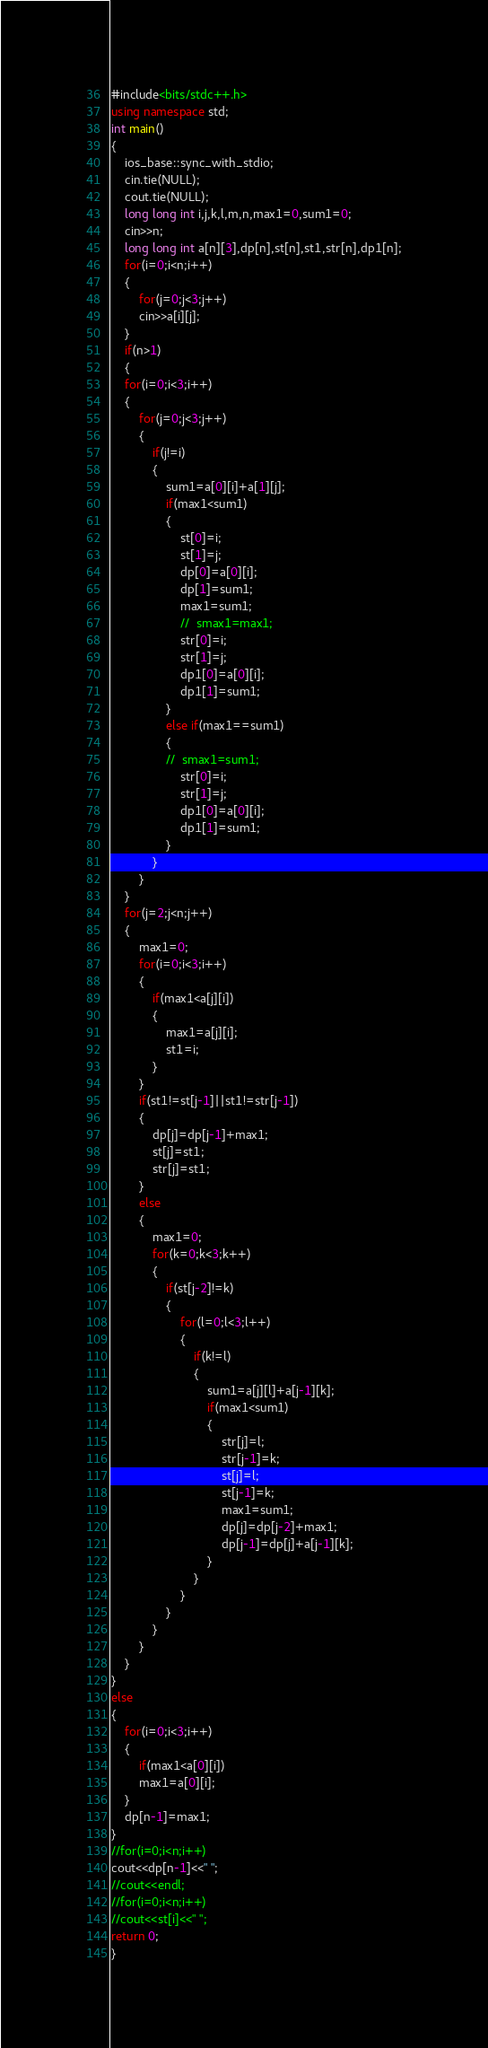Convert code to text. <code><loc_0><loc_0><loc_500><loc_500><_C++_>#include<bits/stdc++.h>
using namespace std;
int main()
{
	ios_base::sync_with_stdio;
	cin.tie(NULL);
	cout.tie(NULL);
	long long int i,j,k,l,m,n,max1=0,sum1=0;
	cin>>n;
	long long int a[n][3],dp[n],st[n],st1,str[n],dp1[n];
	for(i=0;i<n;i++)
	{
		for(j=0;j<3;j++)
		cin>>a[i][j];
	}
	if(n>1)
	{
	for(i=0;i<3;i++)
	{
		for(j=0;j<3;j++)
		{
			if(j!=i)
			{
				sum1=a[0][i]+a[1][j];
				if(max1<sum1)
				{
					st[0]=i;
					st[1]=j;
					dp[0]=a[0][i];
					dp[1]=sum1;
					max1=sum1;
					//	smax1=max1;
					str[0]=i;
					str[1]=j;
					dp1[0]=a[0][i];
					dp1[1]=sum1;
				}
				else if(max1==sum1)
				{
				//	smax1=sum1;
					str[0]=i;
					str[1]=j;
					dp1[0]=a[0][i];
					dp1[1]=sum1;
				}
			}
		}
	}
	for(j=2;j<n;j++)
	{
		max1=0;
		for(i=0;i<3;i++)
		{
			if(max1<a[j][i])
			{
				max1=a[j][i];
				st1=i;
			}
		}
		if(st1!=st[j-1]||st1!=str[j-1])
		{
			dp[j]=dp[j-1]+max1;
			st[j]=st1;
			str[j]=st1;
		}
		else
		{
			max1=0;
			for(k=0;k<3;k++)
			{
				if(st[j-2]!=k)
				{
					for(l=0;l<3;l++)
					{
						if(k!=l)
						{
							sum1=a[j][l]+a[j-1][k];
							if(max1<sum1)
							{
								str[j]=l;
								str[j-1]=k;
								st[j]=l;
								st[j-1]=k;
								max1=sum1;
								dp[j]=dp[j-2]+max1;
								dp[j-1]=dp[j]+a[j-1][k];
							}
						}
					}
				}
			}
		}
	}
}
else
{
	for(i=0;i<3;i++)
	{
		if(max1<a[0][i])
		max1=a[0][i];
	}
	dp[n-1]=max1;
}
//for(i=0;i<n;i++)
cout<<dp[n-1]<<" ";
//cout<<endl;
//for(i=0;i<n;i++)
//cout<<st[i]<<" ";
return 0;
}</code> 